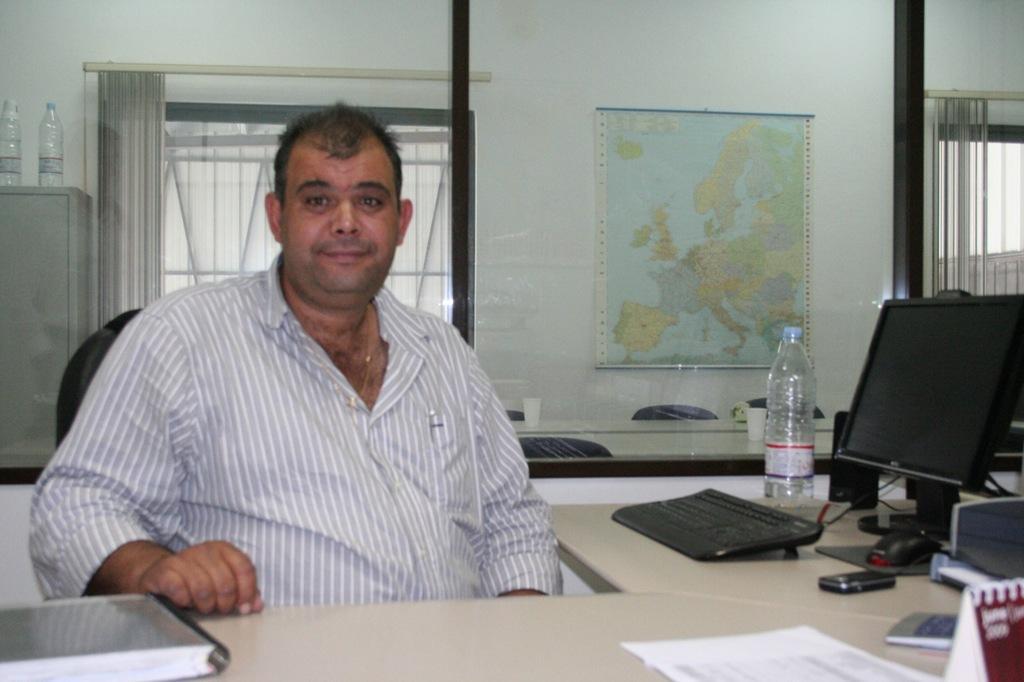How would you summarize this image in a sentence or two? In this image there is a person wearing white color shirt sitting on the chair and on the top of the table there is a system,water bottle,book and at the background of the image there is a world outline and water bottle. 